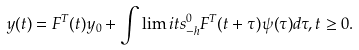<formula> <loc_0><loc_0><loc_500><loc_500>y ( t ) = F ^ { T } ( t ) y _ { 0 } + \int \lim i t s _ { - h } ^ { 0 } F ^ { T } ( t + \tau ) \psi ( \tau ) d \tau , t \geq 0 .</formula> 